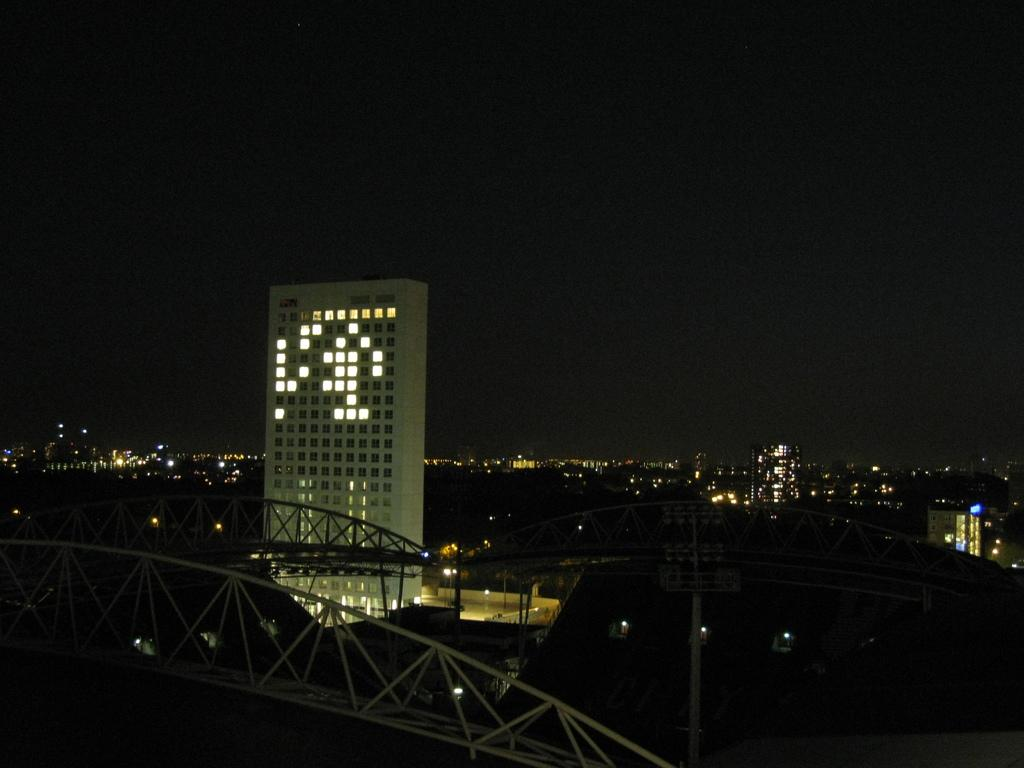What structure is the main subject of the image? There is a bridge in the image. What feature can be observed on the bridge? The bridge has poles. What else is visible in the image besides the bridge? There is a group of buildings in the image. What architectural details can be seen on the buildings? The buildings have windows and lights. What part of the natural environment is visible in the image? The sky is visible in the image. What type of stocking is hanging on the side of the bridge in the image? There is no stocking present in the image, and therefore no such item can be observed. 